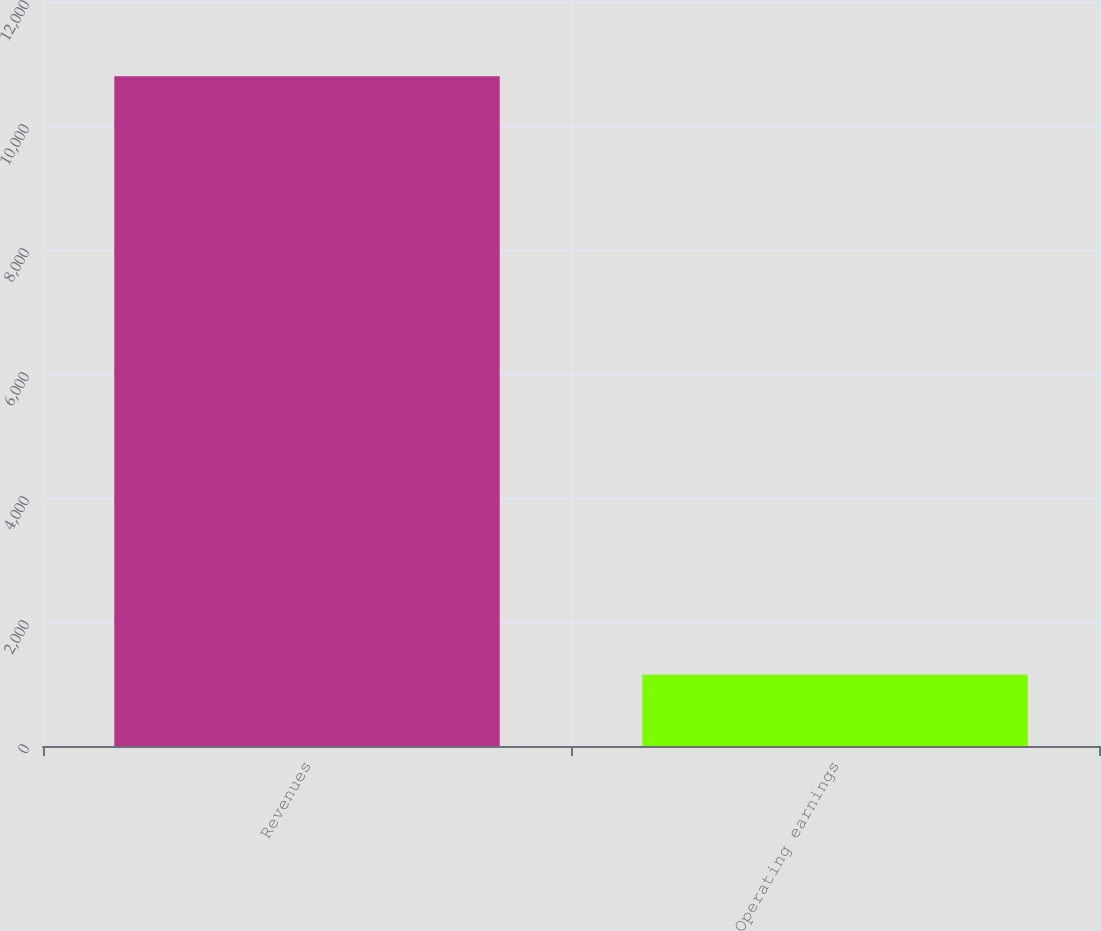<chart> <loc_0><loc_0><loc_500><loc_500><bar_chart><fcel>Revenues<fcel>Operating earnings<nl><fcel>10802<fcel>1151<nl></chart> 